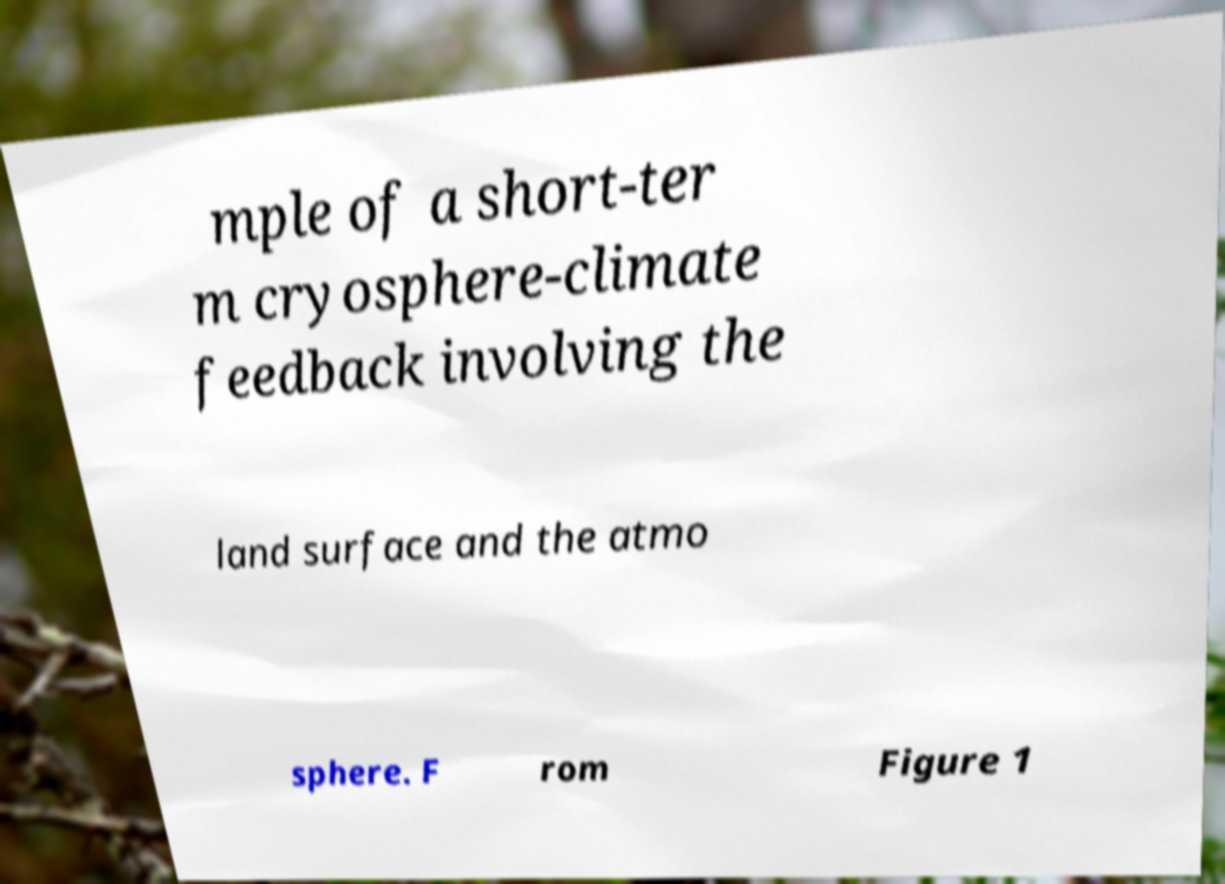Could you assist in decoding the text presented in this image and type it out clearly? mple of a short-ter m cryosphere-climate feedback involving the land surface and the atmo sphere. F rom Figure 1 